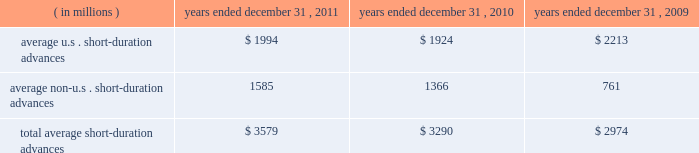Average securities purchased under resale agreements increased to $ 4.69 billion for the year ended december 31 , 2011 from $ 2.96 billion for the year ended december 31 , 2010 .
Average trading account assets increased to $ 2.01 billion for the year ended december 31 , 2011 from $ 376 million for 2010 .
Averages benefited largely from an increase in client demand associated with our trading activities .
In connection with these activities , we traded in highly liquid fixed-income securities as principal with our custody clients and other third- parties that trade in these securities .
Our average investment securities portfolio increased to $ 103.08 billion for the year ended december 31 , 2011 from $ 96.12 billion for 2010 .
The increase was generally the result of ongoing purchases of securities , partly offset by maturities and sales .
In december 2010 , we repositioned our portfolio by selling approximately $ 11 billion of mortgage- and asset-backed securities and re-investing approximately $ 7 billion of the proceeds , primarily in agency mortgage-backed securities .
The repositioning was undertaken to enhance our regulatory capital ratios under evolving regulatory capital standards , increase our balance sheet flexibility in deploying our capital , and reduce our exposure to certain asset classes .
During 2011 , we purchased $ 54 billion of highly rated u.s .
Treasury securities , federal agency mortgage-backed securities and u.s .
And non-u.s .
Asset-backed securities .
As of december 31 , 2011 , securities rated 201caaa 201d and 201caa 201d comprised approximately 89% ( 89 % ) of our portfolio , compared to 90% ( 90 % ) rated 201caaa 201d and 201caa 201d as of december 31 , 2010 .
Loans and leases averaged $ 12.18 billion for the year ended december 31 , 2011 , compared to $ 12.09 billion for 2010 .
The increases primarily resulted from higher client demand for short-duration liquidity , offset in part by a decrease in leases and the purchased receivables added in connection with the conduit consolidation , mainly from maturities and pay-downs .
For 2011 and 2010 , approximately 29% ( 29 % ) and 27% ( 27 % ) , respectively , of our average loan and lease portfolio was composed of short-duration advances that provided liquidity to clients in support of their investment activities related to securities settlement .
The table presents average u.s .
And non-u.s .
Short-duration advances for the years indicated: .
For the year ended december 31 , 2011 , the increase in average non-u.s .
Short-duration advances compared to the prior-year period was mainly due to activity associated with clients added in connection with the acquired intesa securities services business .
Average other interest-earning assets increased to $ 5.46 billion for the year ended december 31 , 2011 from $ 1.16 billion for 2010 .
The increase was primarily the result of higher levels of cash collateral provided in connection with our role as principal in certain securities borrowing activities .
Average interest-bearing deposits increased to $ 88.06 billion for the year ended december 31 , 2011 from $ 76.96 billion for 2010 .
The increase reflected client deposits added in connection with the may 2010 acquisition of the intesa securities services business , and higher levels of non-u.s .
Transaction accounts associated with new and existing business in assets under custody and administration .
Average other short-term borrowings declined to $ 5.13 billion for the year ended december 31 , 2011 from $ 13.59 billion for 2010 , as the higher levels of client deposits provided additional liquidity .
Average long-term debt increased to $ 8.97 billion for the year ended december 31 , 2011 from $ 8.68 billion for the same period in 2010 .
The increase primarily reflected the issuance of an aggregate of $ 2 billion of senior notes by us in march 2011 , partly offset by the maturities of $ 1 billion of senior notes in february 2011 and $ 1.45 billion of senior notes in september 2011 , both previously issued by state street bank under the fdic 2019s temporary liquidity guarantee program .
Additional information about our long-term debt is provided in note 9 to the consolidated financial statements included under item 8. .
What was the change in average other interest-earning assets in 2011 in millions? 
Computations: (5.46 - 1.16)
Answer: 4.3. 